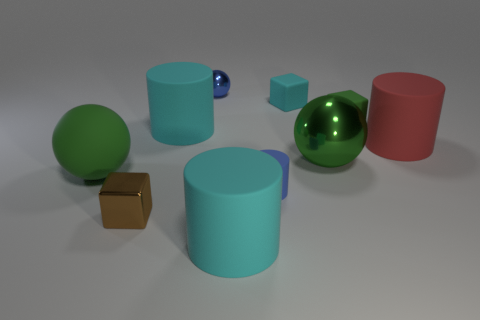Subtract all small cylinders. How many cylinders are left? 3 Subtract all green cylinders. Subtract all red balls. How many cylinders are left? 4 Subtract all spheres. How many objects are left? 7 Add 4 big red cylinders. How many big red cylinders are left? 5 Add 4 tiny cyan objects. How many tiny cyan objects exist? 5 Subtract 1 red cylinders. How many objects are left? 9 Subtract all brown objects. Subtract all small yellow metallic spheres. How many objects are left? 9 